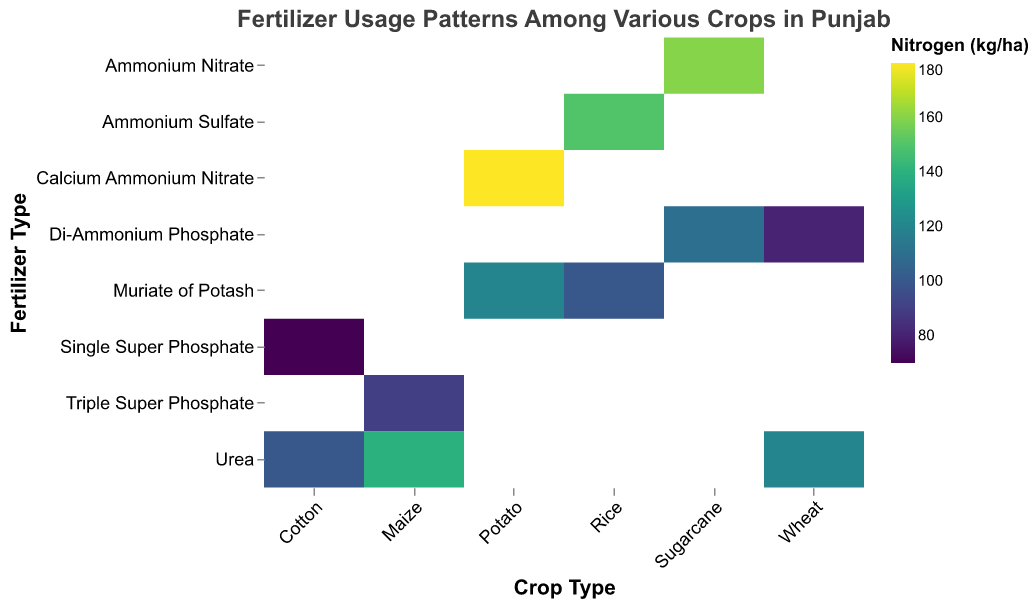What is the title of the heatmap? The title of the heatmap is located at the top and reads "Fertilizer Usage Patterns Among Various Crops in Punjab".
Answer: Fertilizer Usage Patterns Among Various Crops in Punjab Which crop has the highest nitrogen usage when considering Urea as the fertilizer? By examining the color intensity in the Urea row across different crops, Potato stands out with a darker shade indicating higher nitrogen usage.
Answer: Potato What is the nitrogen usage for Wheat with Di-Ammonium Phosphate as the fertilizer? By looking at the intersection of Wheat on the x-axis and Di-Ammonium Phosphate on the y-axis, the tooltip or color legend indicates a nitrogen usage.
Answer: 80 kg/ha Which crop-fertilizer combination has the highest phosphorus usage? Checking the tooltip values for each intersection, Rice with Muriate of Potash shows the highest phosphorus value of 75 kg/ha.
Answer: Rice with Muriate of Potash Compare the potassium usage between Sugarcane with Ammonium Nitrate and Maize with Urea. Look at the intersection points for Sugarcane with Ammonium Nitrate and Maize with Urea on the heatmap, and check their potassium values. Sugarcane with Ammonium Nitrate has 60 kg/ha, and Maize with Urea has 40 kg/ha.
Answer: Sugarcane with Ammonium Nitrate has higher potassium usage Which crop has the most diverse range of fertilizers used in terms of the number of different types of fertilizer? By counting the unique fertilizers listed for each crop on the y-axis, it is noticed that Potato and Sugarcane each have two different fertilizers mentioned.
Answer: Potato and Sugarcane What is the average nitrogen usage for Cotton across all fertilizers? The nitrogen values for Cotton are 100 kg/ha with Urea and 70 kg/ha with Single Super Phosphate. Summing these gives 170 kg/ha and averaging them (170/2) provides 85 kg/ha.
Answer: 85 kg/ha How does the phosphorus usage for Wheat with Urea compare to Wheat with Di-Ammonium Phosphate? By comparing the tooltip values at the intersection for Wheat with both fertilizers, Wheat with Urea has 60 kg/ha of phosphorus, while Wheat with Di-Ammonium Phosphate has 45 kg/ha.
Answer: Wheat with Urea has higher phosphorus usage What is the total nitrogen usage for Potato across all fertilizers? The nitrogen values for Potato with Calcium Ammonium Nitrate and Muriate of Potash are 180 kg/ha and 120 kg/ha, respectively. Summing these gives a total of 300 kg/ha.
Answer: 300 kg/ha 